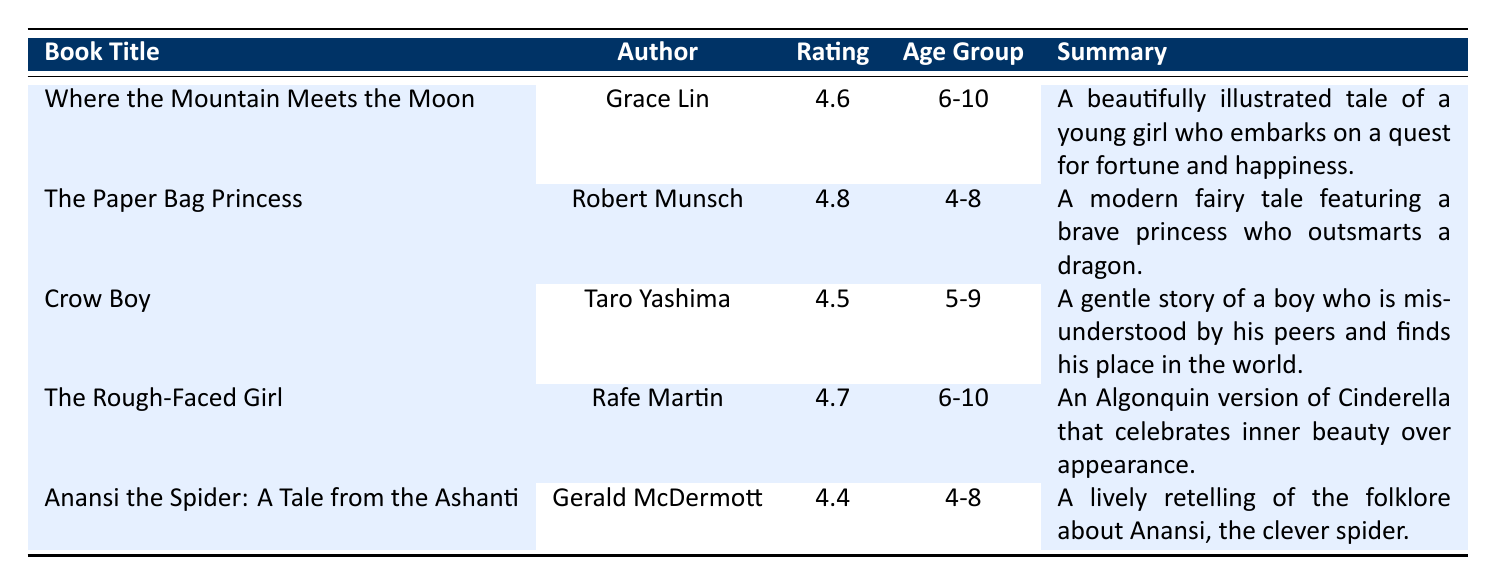What is the reader rating of "The Paper Bag Princess"? The table lists "The Paper Bag Princess" under the book title column with a corresponding rating of 4.8 in the reader rating column.
Answer: 4.8 How many reviews does "Crow Boy" have? Looking in the table, "Crow Boy" is listed with a number of reviews as 800 in the corresponding column.
Answer: 800 Which book has the highest reader rating? By comparing the ratings in the table, "The Paper Bag Princess" has the highest rating of 4.8 among all listed books.
Answer: The Paper Bag Princess Are there any books targeted for the age group of 5-9? The table lists "Crow Boy," which is aimed at the age group of 5-9, confirming there is at least one book for this age group.
Answer: Yes What is the average reader rating of the books targeted for the age group of 4-8? The ratings for books in the 4-8 age group are "The Paper Bag Princess" (4.8) and "Anansi the Spider: A Tale from the Ashanti" (4.4). Calculating the average: (4.8 + 4.4) / 2 = 4.6.
Answer: 4.6 How many total reviews are there for all the listed books? The total number of reviews can be calculated by adding the reviews from all books: 1200 + 1500 + 800 + 600 + 750 = 3850.
Answer: 3850 Which book summaries discuss themes of inner beauty? Referring to the table, "The Rough-Faced Girl" highlights the theme of inner beauty in its summary.
Answer: The Rough-Faced Girl Is "Where the Mountain Meets the Moon" rated lower than 4.5? The table shows that "Where the Mountain Meets the Moon" has a rating of 4.6, which is higher than 4.5.
Answer: No What is the total number of reviews for books written by Robert Munsch? Checking the table, I find that Robert Munsch’s book, "The Paper Bag Princess," has 1500 reviews. Since he is the only author in this query, the total is 1500.
Answer: 1500 